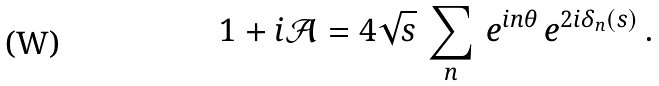Convert formula to latex. <formula><loc_0><loc_0><loc_500><loc_500>1 + i \mathcal { A } = 4 \sqrt { s } \, \sum _ { n } \, e ^ { i n \theta } \, e ^ { 2 i \delta _ { n } \left ( s \right ) } \, .</formula> 